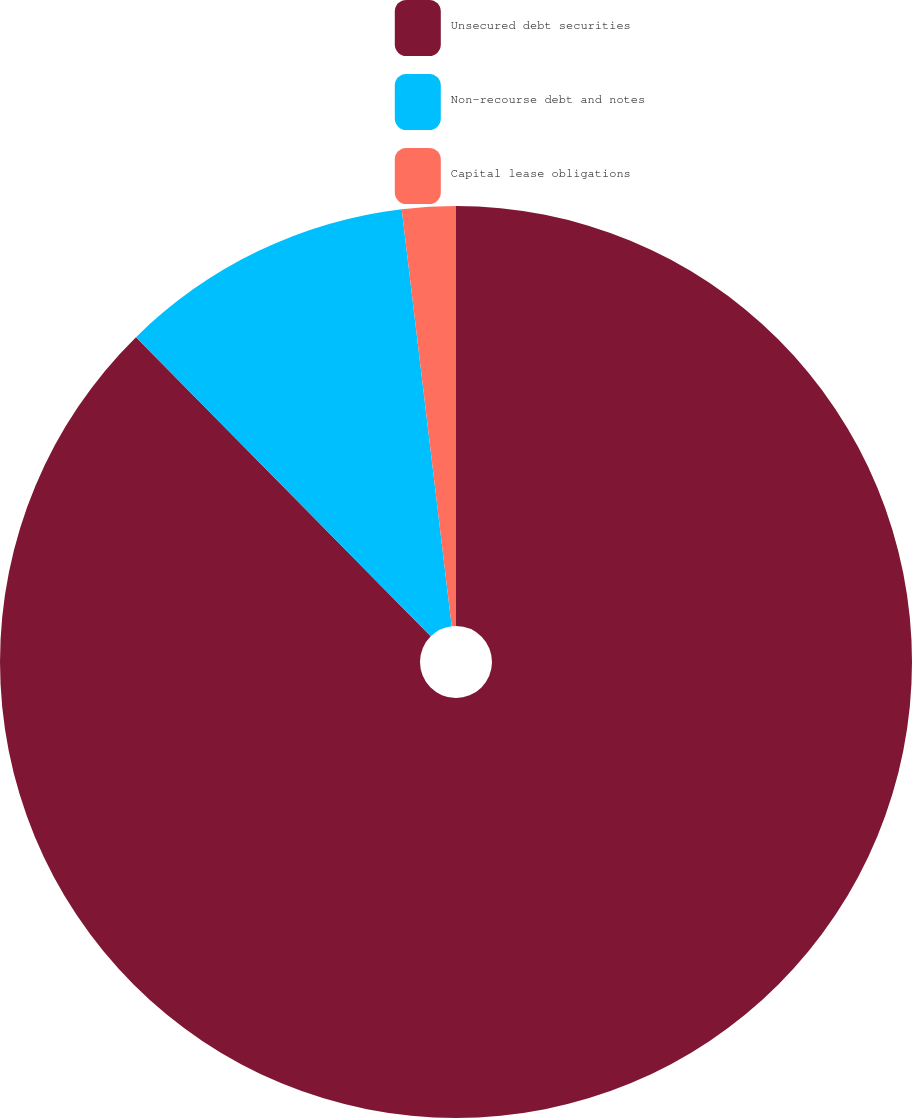Convert chart. <chart><loc_0><loc_0><loc_500><loc_500><pie_chart><fcel>Unsecured debt securities<fcel>Non-recourse debt and notes<fcel>Capital lease obligations<nl><fcel>87.62%<fcel>10.48%<fcel>1.9%<nl></chart> 